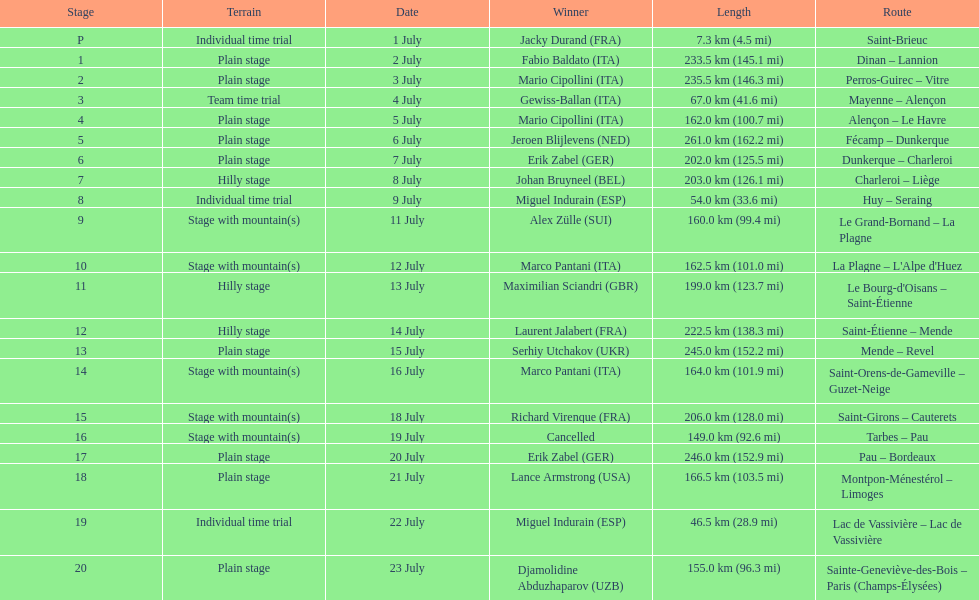Which routes were at least 100 km? Dinan - Lannion, Perros-Guirec - Vitre, Alençon - Le Havre, Fécamp - Dunkerque, Dunkerque - Charleroi, Charleroi - Liège, Le Grand-Bornand - La Plagne, La Plagne - L'Alpe d'Huez, Le Bourg-d'Oisans - Saint-Étienne, Saint-Étienne - Mende, Mende - Revel, Saint-Orens-de-Gameville - Guzet-Neige, Saint-Girons - Cauterets, Tarbes - Pau, Pau - Bordeaux, Montpon-Ménestérol - Limoges, Sainte-Geneviève-des-Bois - Paris (Champs-Élysées). 